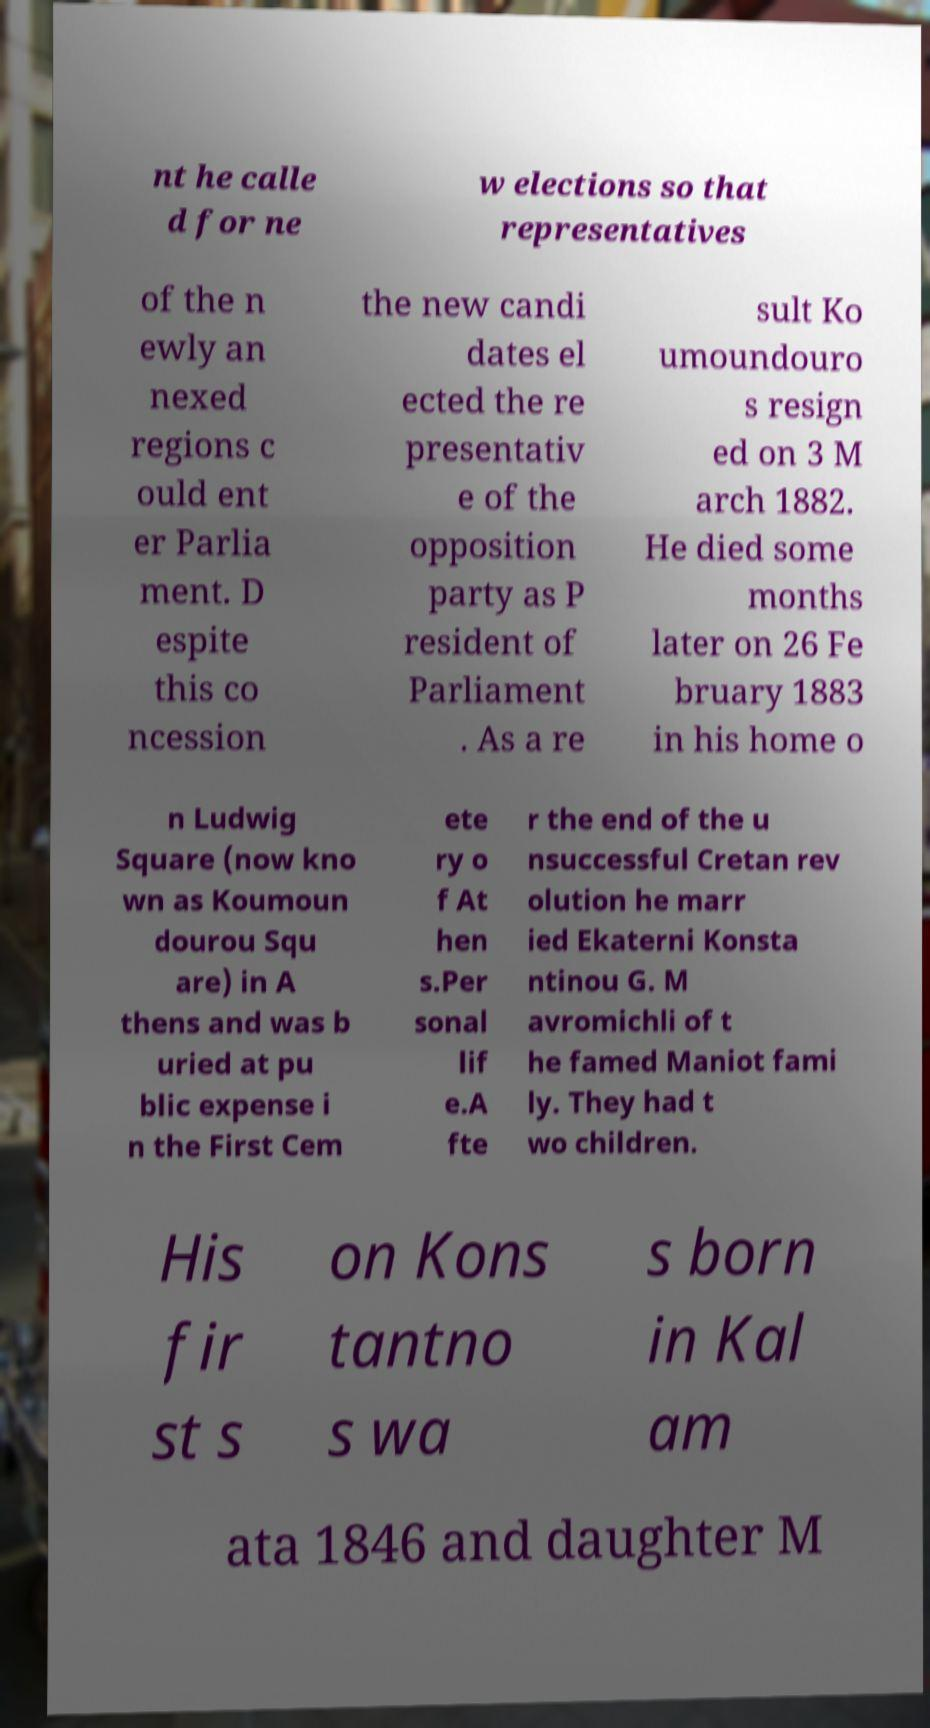What messages or text are displayed in this image? I need them in a readable, typed format. nt he calle d for ne w elections so that representatives of the n ewly an nexed regions c ould ent er Parlia ment. D espite this co ncession the new candi dates el ected the re presentativ e of the opposition party as P resident of Parliament . As a re sult Ko umoundouro s resign ed on 3 M arch 1882. He died some months later on 26 Fe bruary 1883 in his home o n Ludwig Square (now kno wn as Koumoun dourou Squ are) in A thens and was b uried at pu blic expense i n the First Cem ete ry o f At hen s.Per sonal lif e.A fte r the end of the u nsuccessful Cretan rev olution he marr ied Ekaterni Konsta ntinou G. M avromichli of t he famed Maniot fami ly. They had t wo children. His fir st s on Kons tantno s wa s born in Kal am ata 1846 and daughter M 